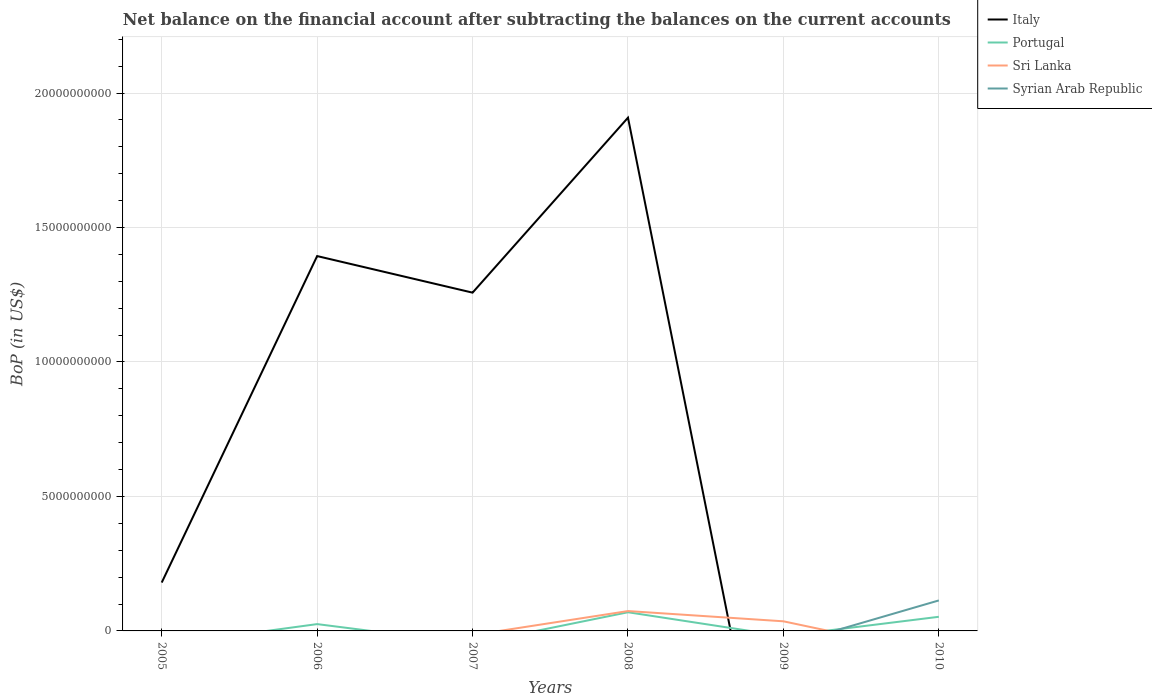Does the line corresponding to Syrian Arab Republic intersect with the line corresponding to Sri Lanka?
Provide a succinct answer. Yes. Is the number of lines equal to the number of legend labels?
Your answer should be compact. No. What is the total Balance of Payments in Italy in the graph?
Offer a terse response. -1.08e+1. What is the difference between the highest and the second highest Balance of Payments in Sri Lanka?
Provide a succinct answer. 7.39e+08. What is the difference between the highest and the lowest Balance of Payments in Sri Lanka?
Your answer should be compact. 2. How many years are there in the graph?
Give a very brief answer. 6. What is the difference between two consecutive major ticks on the Y-axis?
Ensure brevity in your answer.  5.00e+09. Are the values on the major ticks of Y-axis written in scientific E-notation?
Offer a terse response. No. Does the graph contain any zero values?
Ensure brevity in your answer.  Yes. How many legend labels are there?
Keep it short and to the point. 4. How are the legend labels stacked?
Your answer should be compact. Vertical. What is the title of the graph?
Offer a terse response. Net balance on the financial account after subtracting the balances on the current accounts. What is the label or title of the Y-axis?
Your answer should be compact. BoP (in US$). What is the BoP (in US$) in Italy in 2005?
Keep it short and to the point. 1.80e+09. What is the BoP (in US$) of Portugal in 2005?
Provide a short and direct response. 0. What is the BoP (in US$) in Syrian Arab Republic in 2005?
Provide a short and direct response. 0. What is the BoP (in US$) of Italy in 2006?
Keep it short and to the point. 1.39e+1. What is the BoP (in US$) in Portugal in 2006?
Provide a short and direct response. 2.53e+08. What is the BoP (in US$) in Sri Lanka in 2006?
Provide a short and direct response. 0. What is the BoP (in US$) in Syrian Arab Republic in 2006?
Give a very brief answer. 0. What is the BoP (in US$) in Italy in 2007?
Your answer should be compact. 1.26e+1. What is the BoP (in US$) in Syrian Arab Republic in 2007?
Offer a very short reply. 0. What is the BoP (in US$) of Italy in 2008?
Ensure brevity in your answer.  1.91e+1. What is the BoP (in US$) of Portugal in 2008?
Offer a terse response. 6.94e+08. What is the BoP (in US$) in Sri Lanka in 2008?
Keep it short and to the point. 7.39e+08. What is the BoP (in US$) of Syrian Arab Republic in 2008?
Give a very brief answer. 0. What is the BoP (in US$) of Italy in 2009?
Offer a terse response. 0. What is the BoP (in US$) in Portugal in 2009?
Offer a very short reply. 0. What is the BoP (in US$) of Sri Lanka in 2009?
Provide a short and direct response. 3.58e+08. What is the BoP (in US$) of Syrian Arab Republic in 2009?
Offer a terse response. 0. What is the BoP (in US$) in Italy in 2010?
Your answer should be very brief. 0. What is the BoP (in US$) in Portugal in 2010?
Provide a short and direct response. 5.25e+08. What is the BoP (in US$) of Sri Lanka in 2010?
Offer a terse response. 0. What is the BoP (in US$) of Syrian Arab Republic in 2010?
Offer a terse response. 1.13e+09. Across all years, what is the maximum BoP (in US$) of Italy?
Your answer should be very brief. 1.91e+1. Across all years, what is the maximum BoP (in US$) in Portugal?
Your answer should be compact. 6.94e+08. Across all years, what is the maximum BoP (in US$) of Sri Lanka?
Provide a short and direct response. 7.39e+08. Across all years, what is the maximum BoP (in US$) in Syrian Arab Republic?
Provide a succinct answer. 1.13e+09. Across all years, what is the minimum BoP (in US$) in Portugal?
Offer a terse response. 0. Across all years, what is the minimum BoP (in US$) of Sri Lanka?
Your answer should be compact. 0. What is the total BoP (in US$) of Italy in the graph?
Keep it short and to the point. 4.74e+1. What is the total BoP (in US$) in Portugal in the graph?
Give a very brief answer. 1.47e+09. What is the total BoP (in US$) of Sri Lanka in the graph?
Give a very brief answer. 1.10e+09. What is the total BoP (in US$) in Syrian Arab Republic in the graph?
Your answer should be compact. 1.13e+09. What is the difference between the BoP (in US$) of Italy in 2005 and that in 2006?
Your answer should be compact. -1.21e+1. What is the difference between the BoP (in US$) in Italy in 2005 and that in 2007?
Offer a very short reply. -1.08e+1. What is the difference between the BoP (in US$) in Italy in 2005 and that in 2008?
Provide a short and direct response. -1.73e+1. What is the difference between the BoP (in US$) in Italy in 2006 and that in 2007?
Your response must be concise. 1.36e+09. What is the difference between the BoP (in US$) of Italy in 2006 and that in 2008?
Offer a terse response. -5.15e+09. What is the difference between the BoP (in US$) of Portugal in 2006 and that in 2008?
Ensure brevity in your answer.  -4.41e+08. What is the difference between the BoP (in US$) of Portugal in 2006 and that in 2010?
Provide a short and direct response. -2.72e+08. What is the difference between the BoP (in US$) of Italy in 2007 and that in 2008?
Offer a terse response. -6.51e+09. What is the difference between the BoP (in US$) in Sri Lanka in 2008 and that in 2009?
Your response must be concise. 3.81e+08. What is the difference between the BoP (in US$) in Portugal in 2008 and that in 2010?
Your answer should be very brief. 1.69e+08. What is the difference between the BoP (in US$) of Italy in 2005 and the BoP (in US$) of Portugal in 2006?
Ensure brevity in your answer.  1.55e+09. What is the difference between the BoP (in US$) of Italy in 2005 and the BoP (in US$) of Portugal in 2008?
Your answer should be very brief. 1.10e+09. What is the difference between the BoP (in US$) of Italy in 2005 and the BoP (in US$) of Sri Lanka in 2008?
Your answer should be compact. 1.06e+09. What is the difference between the BoP (in US$) of Italy in 2005 and the BoP (in US$) of Sri Lanka in 2009?
Keep it short and to the point. 1.44e+09. What is the difference between the BoP (in US$) in Italy in 2005 and the BoP (in US$) in Portugal in 2010?
Your response must be concise. 1.27e+09. What is the difference between the BoP (in US$) of Italy in 2005 and the BoP (in US$) of Syrian Arab Republic in 2010?
Provide a short and direct response. 6.65e+08. What is the difference between the BoP (in US$) in Italy in 2006 and the BoP (in US$) in Portugal in 2008?
Make the answer very short. 1.32e+1. What is the difference between the BoP (in US$) in Italy in 2006 and the BoP (in US$) in Sri Lanka in 2008?
Keep it short and to the point. 1.32e+1. What is the difference between the BoP (in US$) in Portugal in 2006 and the BoP (in US$) in Sri Lanka in 2008?
Provide a short and direct response. -4.85e+08. What is the difference between the BoP (in US$) of Italy in 2006 and the BoP (in US$) of Sri Lanka in 2009?
Offer a very short reply. 1.36e+1. What is the difference between the BoP (in US$) in Portugal in 2006 and the BoP (in US$) in Sri Lanka in 2009?
Keep it short and to the point. -1.04e+08. What is the difference between the BoP (in US$) in Italy in 2006 and the BoP (in US$) in Portugal in 2010?
Provide a succinct answer. 1.34e+1. What is the difference between the BoP (in US$) of Italy in 2006 and the BoP (in US$) of Syrian Arab Republic in 2010?
Keep it short and to the point. 1.28e+1. What is the difference between the BoP (in US$) of Portugal in 2006 and the BoP (in US$) of Syrian Arab Republic in 2010?
Offer a very short reply. -8.81e+08. What is the difference between the BoP (in US$) in Italy in 2007 and the BoP (in US$) in Portugal in 2008?
Give a very brief answer. 1.19e+1. What is the difference between the BoP (in US$) in Italy in 2007 and the BoP (in US$) in Sri Lanka in 2008?
Provide a short and direct response. 1.18e+1. What is the difference between the BoP (in US$) of Italy in 2007 and the BoP (in US$) of Sri Lanka in 2009?
Ensure brevity in your answer.  1.22e+1. What is the difference between the BoP (in US$) in Italy in 2007 and the BoP (in US$) in Portugal in 2010?
Ensure brevity in your answer.  1.21e+1. What is the difference between the BoP (in US$) in Italy in 2007 and the BoP (in US$) in Syrian Arab Republic in 2010?
Your answer should be very brief. 1.14e+1. What is the difference between the BoP (in US$) of Italy in 2008 and the BoP (in US$) of Sri Lanka in 2009?
Make the answer very short. 1.87e+1. What is the difference between the BoP (in US$) of Portugal in 2008 and the BoP (in US$) of Sri Lanka in 2009?
Your response must be concise. 3.37e+08. What is the difference between the BoP (in US$) of Italy in 2008 and the BoP (in US$) of Portugal in 2010?
Keep it short and to the point. 1.86e+1. What is the difference between the BoP (in US$) in Italy in 2008 and the BoP (in US$) in Syrian Arab Republic in 2010?
Give a very brief answer. 1.80e+1. What is the difference between the BoP (in US$) in Portugal in 2008 and the BoP (in US$) in Syrian Arab Republic in 2010?
Provide a short and direct response. -4.40e+08. What is the difference between the BoP (in US$) of Sri Lanka in 2008 and the BoP (in US$) of Syrian Arab Republic in 2010?
Your response must be concise. -3.95e+08. What is the difference between the BoP (in US$) in Sri Lanka in 2009 and the BoP (in US$) in Syrian Arab Republic in 2010?
Offer a very short reply. -7.76e+08. What is the average BoP (in US$) in Italy per year?
Give a very brief answer. 7.90e+09. What is the average BoP (in US$) of Portugal per year?
Keep it short and to the point. 2.45e+08. What is the average BoP (in US$) of Sri Lanka per year?
Offer a terse response. 1.83e+08. What is the average BoP (in US$) of Syrian Arab Republic per year?
Provide a succinct answer. 1.89e+08. In the year 2006, what is the difference between the BoP (in US$) of Italy and BoP (in US$) of Portugal?
Make the answer very short. 1.37e+1. In the year 2008, what is the difference between the BoP (in US$) of Italy and BoP (in US$) of Portugal?
Offer a terse response. 1.84e+1. In the year 2008, what is the difference between the BoP (in US$) in Italy and BoP (in US$) in Sri Lanka?
Offer a very short reply. 1.83e+1. In the year 2008, what is the difference between the BoP (in US$) of Portugal and BoP (in US$) of Sri Lanka?
Provide a succinct answer. -4.43e+07. In the year 2010, what is the difference between the BoP (in US$) of Portugal and BoP (in US$) of Syrian Arab Republic?
Your answer should be compact. -6.09e+08. What is the ratio of the BoP (in US$) of Italy in 2005 to that in 2006?
Ensure brevity in your answer.  0.13. What is the ratio of the BoP (in US$) in Italy in 2005 to that in 2007?
Your response must be concise. 0.14. What is the ratio of the BoP (in US$) in Italy in 2005 to that in 2008?
Offer a very short reply. 0.09. What is the ratio of the BoP (in US$) of Italy in 2006 to that in 2007?
Your answer should be compact. 1.11. What is the ratio of the BoP (in US$) of Italy in 2006 to that in 2008?
Provide a succinct answer. 0.73. What is the ratio of the BoP (in US$) in Portugal in 2006 to that in 2008?
Give a very brief answer. 0.36. What is the ratio of the BoP (in US$) of Portugal in 2006 to that in 2010?
Provide a succinct answer. 0.48. What is the ratio of the BoP (in US$) of Italy in 2007 to that in 2008?
Keep it short and to the point. 0.66. What is the ratio of the BoP (in US$) in Sri Lanka in 2008 to that in 2009?
Offer a terse response. 2.07. What is the ratio of the BoP (in US$) in Portugal in 2008 to that in 2010?
Provide a short and direct response. 1.32. What is the difference between the highest and the second highest BoP (in US$) in Italy?
Keep it short and to the point. 5.15e+09. What is the difference between the highest and the second highest BoP (in US$) in Portugal?
Offer a very short reply. 1.69e+08. What is the difference between the highest and the lowest BoP (in US$) in Italy?
Offer a very short reply. 1.91e+1. What is the difference between the highest and the lowest BoP (in US$) of Portugal?
Your answer should be compact. 6.94e+08. What is the difference between the highest and the lowest BoP (in US$) in Sri Lanka?
Offer a very short reply. 7.39e+08. What is the difference between the highest and the lowest BoP (in US$) in Syrian Arab Republic?
Your answer should be compact. 1.13e+09. 